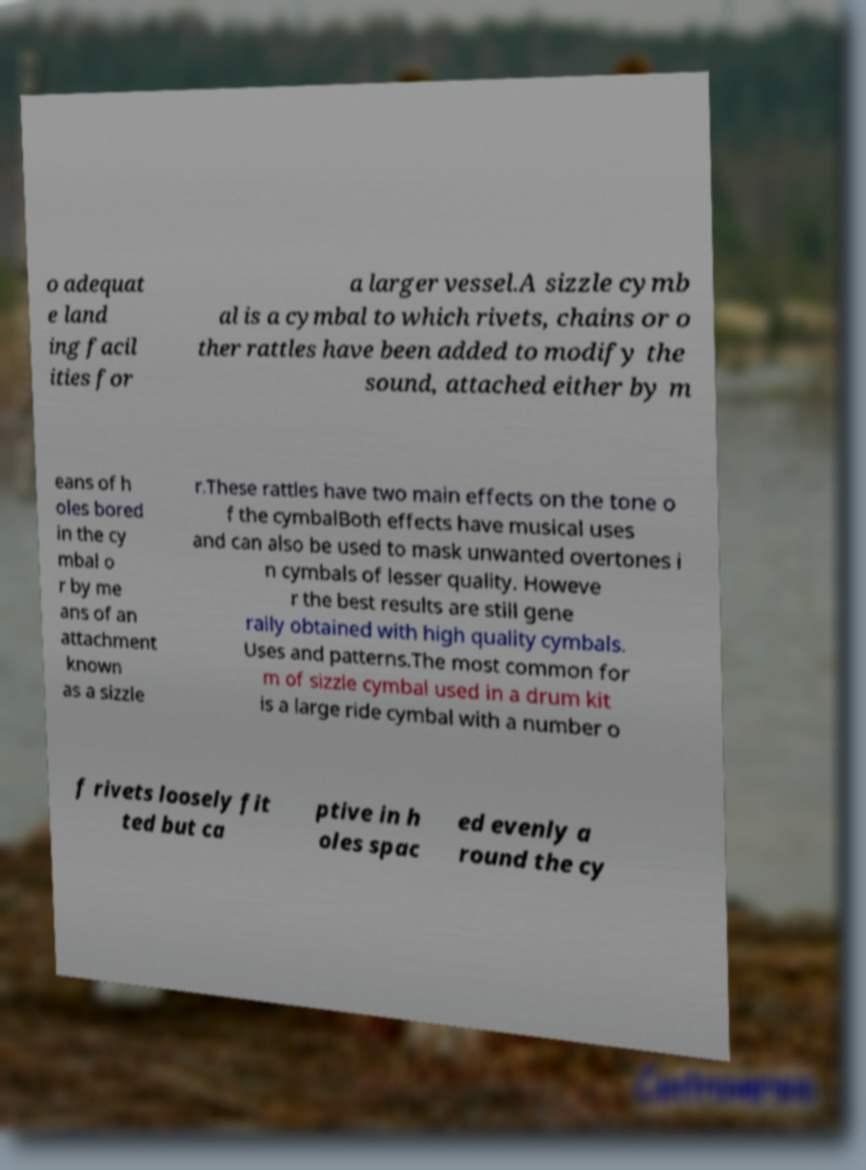Can you read and provide the text displayed in the image?This photo seems to have some interesting text. Can you extract and type it out for me? o adequat e land ing facil ities for a larger vessel.A sizzle cymb al is a cymbal to which rivets, chains or o ther rattles have been added to modify the sound, attached either by m eans of h oles bored in the cy mbal o r by me ans of an attachment known as a sizzle r.These rattles have two main effects on the tone o f the cymbalBoth effects have musical uses and can also be used to mask unwanted overtones i n cymbals of lesser quality. Howeve r the best results are still gene rally obtained with high quality cymbals. Uses and patterns.The most common for m of sizzle cymbal used in a drum kit is a large ride cymbal with a number o f rivets loosely fit ted but ca ptive in h oles spac ed evenly a round the cy 